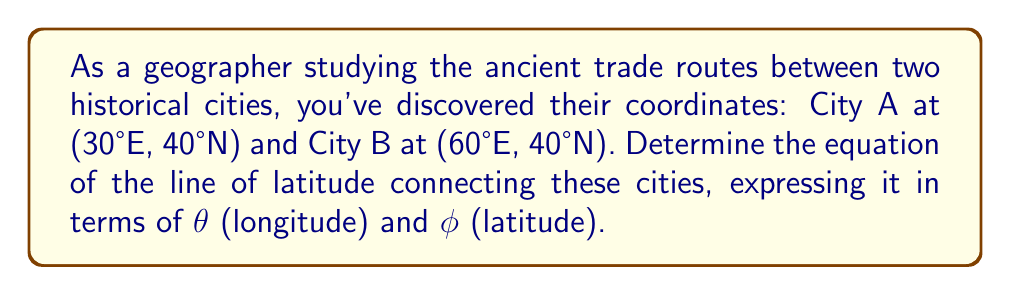What is the answer to this math problem? Let's approach this step-by-step:

1) A line of latitude is a circle parallel to the equator, where all points have the same latitude value.

2) In this case, both cities have the same latitude of 40°N. This means the line of latitude we're looking for is the one at 40°N.

3) The general equation for a line of latitude in terms of $\theta$ (longitude) and $\phi$ (latitude) is:

   $$\phi = \text{constant}$$

4) Here, the constant is 40°N. However, we need to express this in radians for the standard mathematical form.

5) To convert from degrees to radians:
   
   $$40° \times \frac{\pi}{180°} = \frac{2\pi}{9} \text{ radians}$$

6) Therefore, the equation of the line of latitude connecting these two historical cities is:

   $$\phi = \frac{2\pi}{9}$$

This equation holds true for all longitudes $\theta$ between the two cities (30°E to 60°E) and beyond, as it represents a complete circle around the Earth at 40°N latitude.
Answer: $$\phi = \frac{2\pi}{9}$$ 